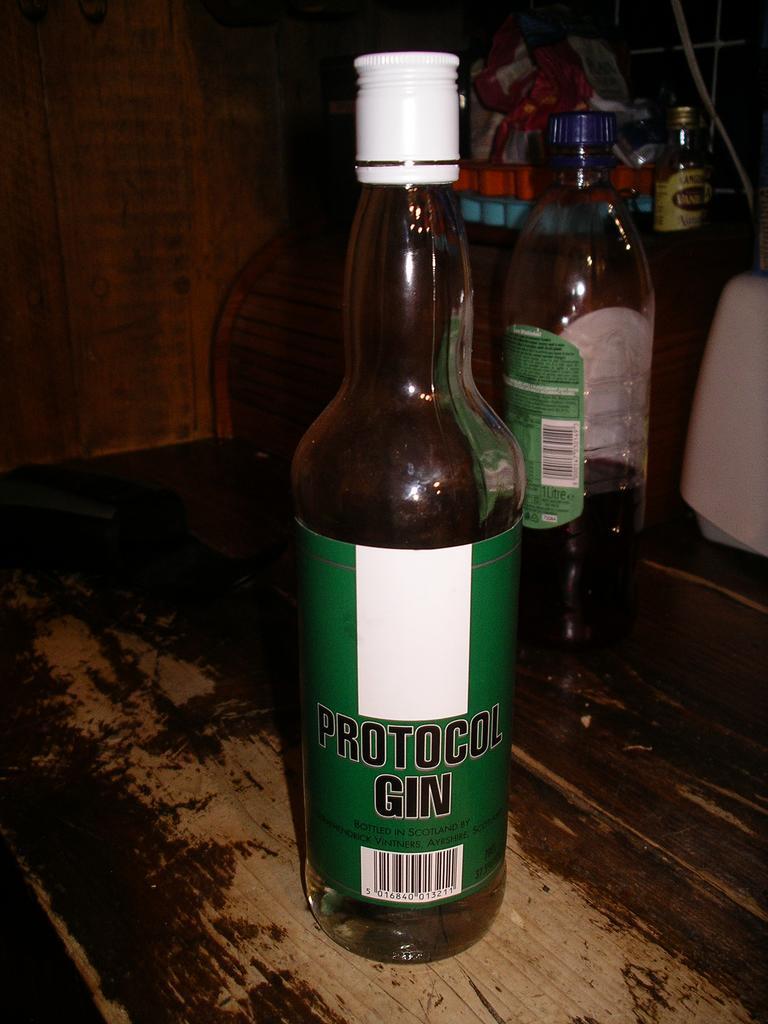What type of alcohol is shown?
Your answer should be compact. Gin. What is the brand name of the gin?
Your answer should be compact. Protocol. 